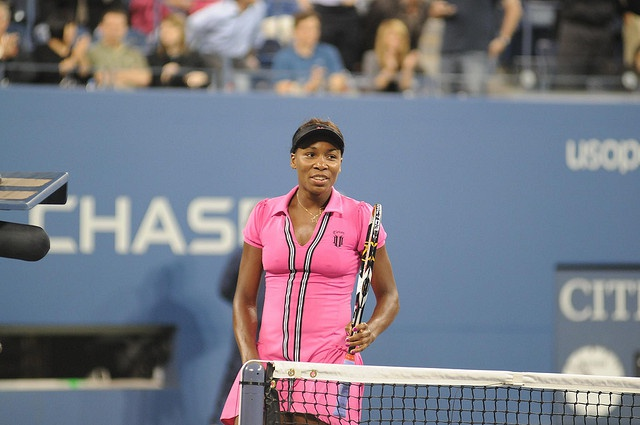Describe the objects in this image and their specific colors. I can see people in gray, lightpink, and brown tones, people in gray, darkgray, and black tones, people in gray and black tones, people in gray, darkgray, and tan tones, and people in gray, darkgray, and lavender tones in this image. 